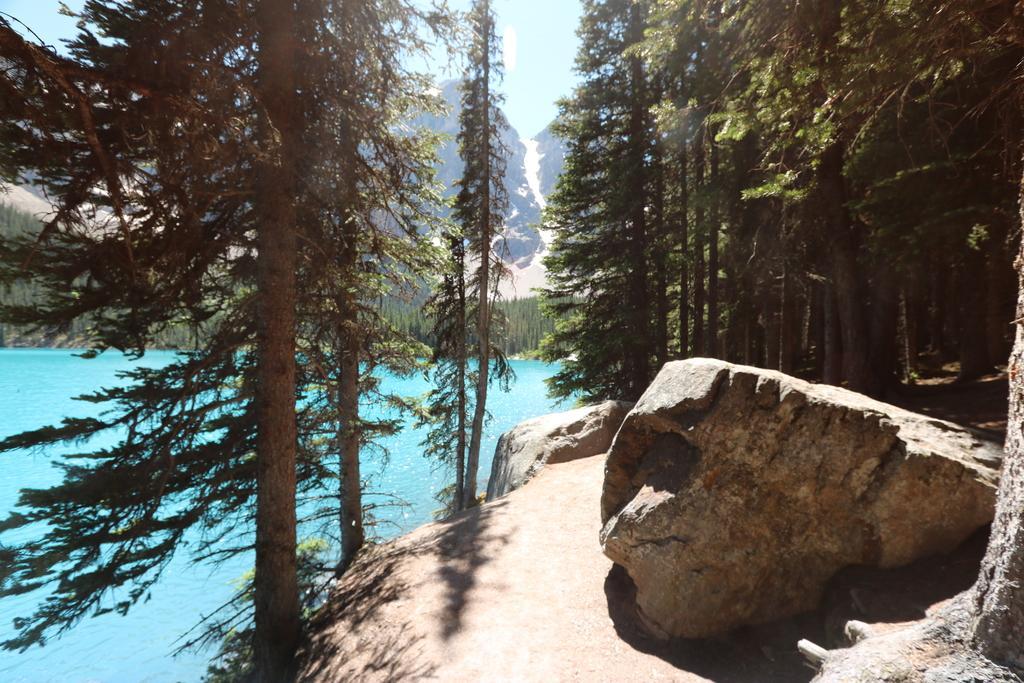Please provide a concise description of this image. In the center of the image there are trees. At the bottom there is a rock. On the left we can see water. In the background there are hills and sky. 